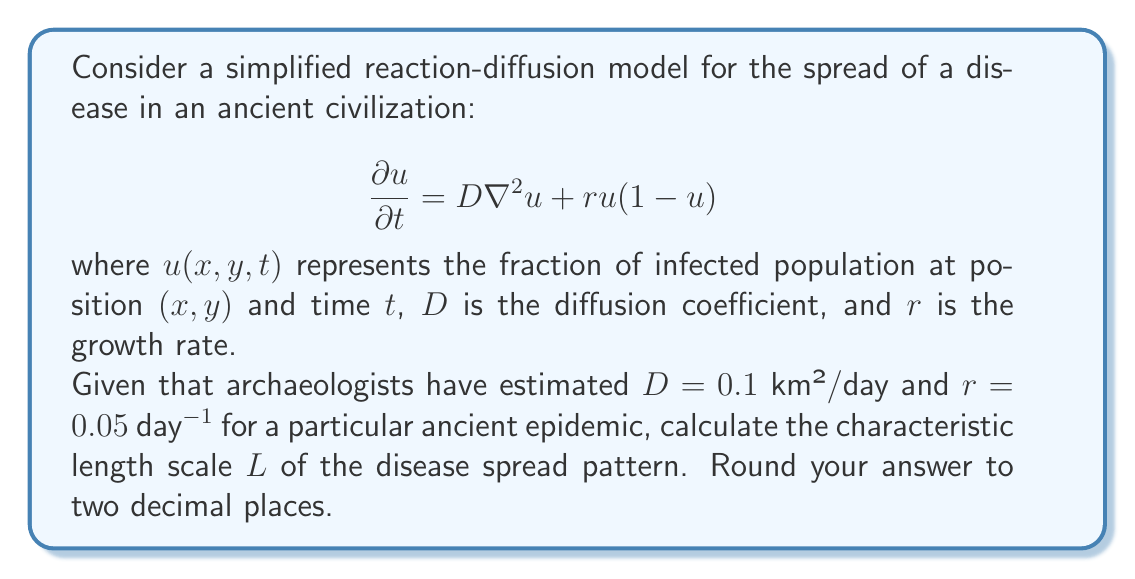Can you solve this math problem? To solve this problem, we need to understand the concept of characteristic length scale in reaction-diffusion equations:

1) The characteristic length scale $L$ represents the typical spatial extent of the pattern formed by the reaction-diffusion process.

2) For a reaction-diffusion equation of the form we have, the characteristic length scale is given by:

   $$L = \sqrt{\frac{D}{r}}$$

3) This formula comes from dimensional analysis and represents the balance between diffusion (spreading) and reaction (local growth) processes.

4) We are given:
   $D = 0.1$ km²/day
   $r = 0.05$ day⁻¹

5) Substituting these values into the formula:

   $$L = \sqrt{\frac{0.1 \text{ km}^2/\text{day}}{0.05 \text{ day}^{-1}}}$$

6) Simplify under the square root:

   $$L = \sqrt{2 \text{ km}^2} = \sqrt{2} \text{ km}$$

7) Calculate the square root:

   $$L \approx 1.4142 \text{ km}$$

8) Rounding to two decimal places:

   $$L \approx 1.41 \text{ km}$$

This result suggests that the typical spatial scale of the disease spread pattern in this ancient epidemic was about 1.41 km.
Answer: $1.41$ km 